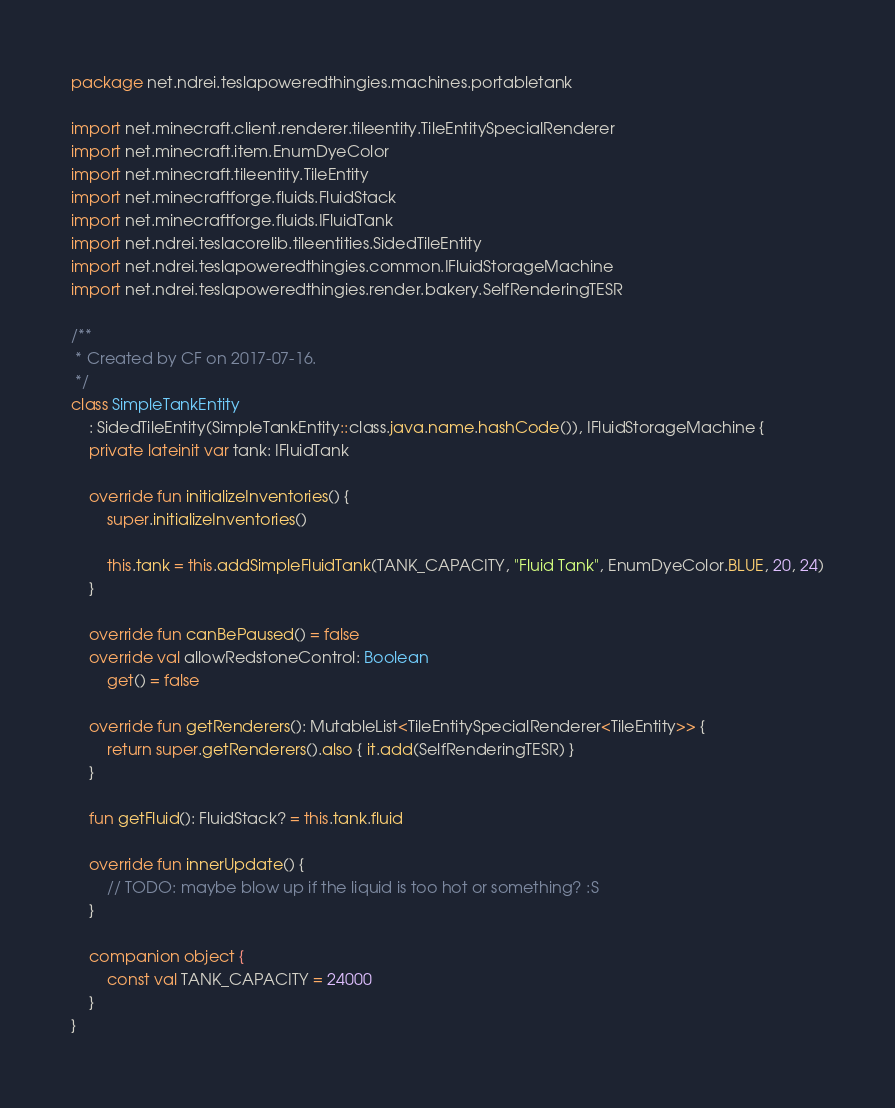<code> <loc_0><loc_0><loc_500><loc_500><_Kotlin_>package net.ndrei.teslapoweredthingies.machines.portabletank

import net.minecraft.client.renderer.tileentity.TileEntitySpecialRenderer
import net.minecraft.item.EnumDyeColor
import net.minecraft.tileentity.TileEntity
import net.minecraftforge.fluids.FluidStack
import net.minecraftforge.fluids.IFluidTank
import net.ndrei.teslacorelib.tileentities.SidedTileEntity
import net.ndrei.teslapoweredthingies.common.IFluidStorageMachine
import net.ndrei.teslapoweredthingies.render.bakery.SelfRenderingTESR

/**
 * Created by CF on 2017-07-16.
 */
class SimpleTankEntity
    : SidedTileEntity(SimpleTankEntity::class.java.name.hashCode()), IFluidStorageMachine {
    private lateinit var tank: IFluidTank

    override fun initializeInventories() {
        super.initializeInventories()

        this.tank = this.addSimpleFluidTank(TANK_CAPACITY, "Fluid Tank", EnumDyeColor.BLUE, 20, 24)
    }

    override fun canBePaused() = false
    override val allowRedstoneControl: Boolean
        get() = false

    override fun getRenderers(): MutableList<TileEntitySpecialRenderer<TileEntity>> {
        return super.getRenderers().also { it.add(SelfRenderingTESR) }
    }

    fun getFluid(): FluidStack? = this.tank.fluid

    override fun innerUpdate() {
        // TODO: maybe blow up if the liquid is too hot or something? :S
    }

    companion object {
        const val TANK_CAPACITY = 24000
    }
}</code> 